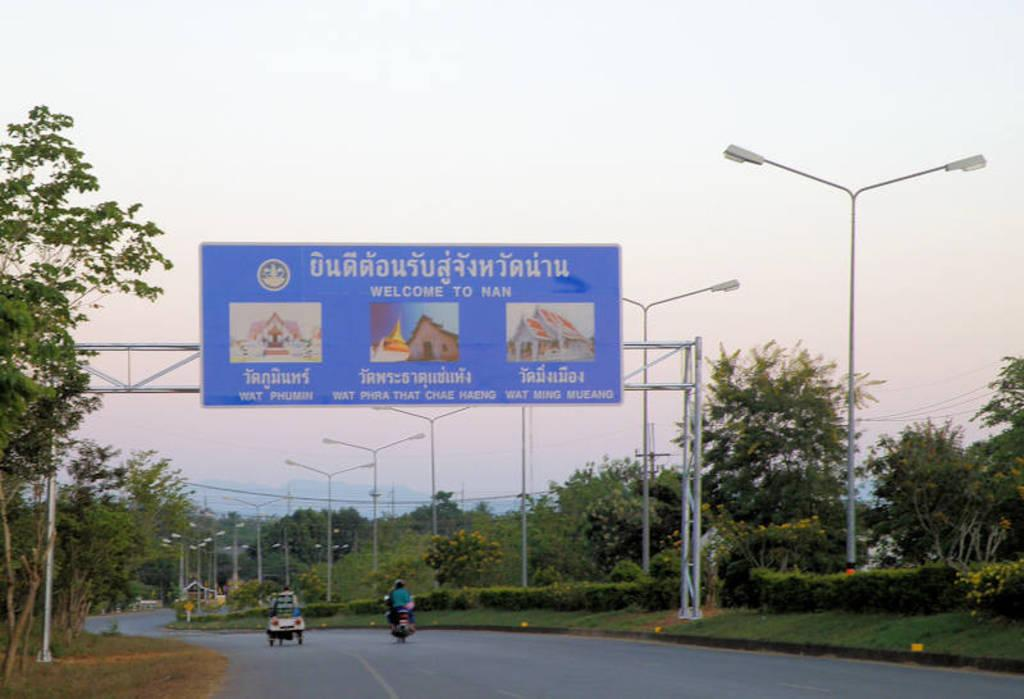Provide a one-sentence caption for the provided image. Blue highway sign says "welcome to Nan" above the highway. 